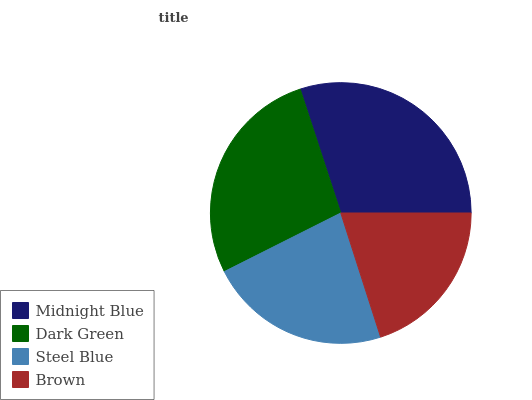Is Brown the minimum?
Answer yes or no. Yes. Is Midnight Blue the maximum?
Answer yes or no. Yes. Is Dark Green the minimum?
Answer yes or no. No. Is Dark Green the maximum?
Answer yes or no. No. Is Midnight Blue greater than Dark Green?
Answer yes or no. Yes. Is Dark Green less than Midnight Blue?
Answer yes or no. Yes. Is Dark Green greater than Midnight Blue?
Answer yes or no. No. Is Midnight Blue less than Dark Green?
Answer yes or no. No. Is Dark Green the high median?
Answer yes or no. Yes. Is Steel Blue the low median?
Answer yes or no. Yes. Is Midnight Blue the high median?
Answer yes or no. No. Is Dark Green the low median?
Answer yes or no. No. 